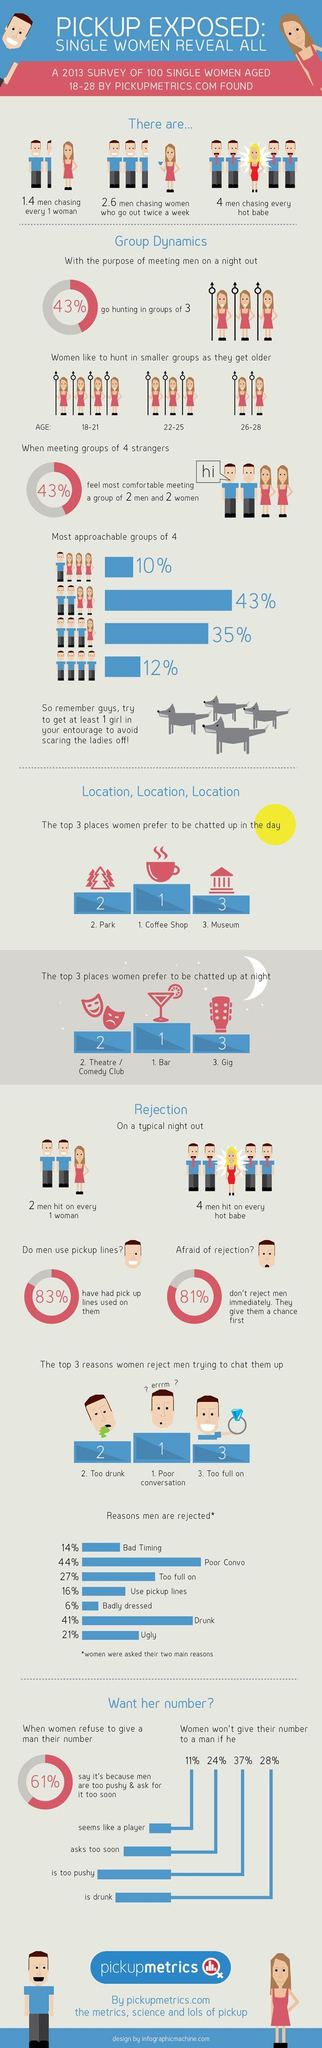Draw attention to some important aspects in this diagram. A significant percentage of women do not give their number to a man if they seem like a player and ask too soon, even if they are taken. There are three girls who are hunting for men in the age range of 22-25. A recent survey found that only 17% of men do not use pickup lines. There are four girls in the group who are hunting for men in the age range of 18-21. According to the survey, 57% of the respondents stated that they are not comfortable meeting a group of 2 men and 2 women. 